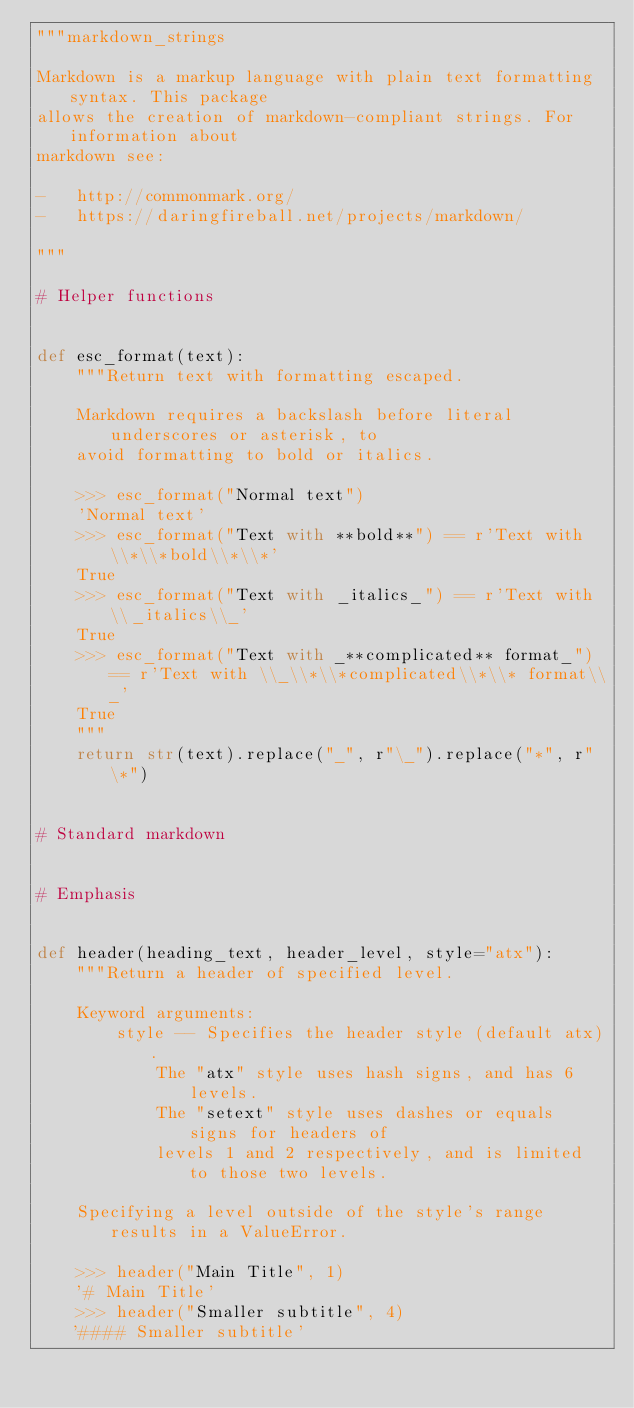Convert code to text. <code><loc_0><loc_0><loc_500><loc_500><_Python_>"""markdown_strings

Markdown is a markup language with plain text formatting syntax. This package
allows the creation of markdown-compliant strings. For information about
markdown see:

-   http://commonmark.org/
-   https://daringfireball.net/projects/markdown/

"""

# Helper functions


def esc_format(text):
    """Return text with formatting escaped.

    Markdown requires a backslash before literal underscores or asterisk, to
    avoid formatting to bold or italics.

    >>> esc_format("Normal text")
    'Normal text'
    >>> esc_format("Text with **bold**") == r'Text with \\*\\*bold\\*\\*'
    True
    >>> esc_format("Text with _italics_") == r'Text with \\_italics\\_'
    True
    >>> esc_format("Text with _**complicated** format_") == r'Text with \\_\\*\\*complicated\\*\\* format\\_'
    True
    """
    return str(text).replace("_", r"\_").replace("*", r"\*")


# Standard markdown


# Emphasis


def header(heading_text, header_level, style="atx"):
    """Return a header of specified level.

    Keyword arguments:
        style -- Specifies the header style (default atx).
            The "atx" style uses hash signs, and has 6 levels.
            The "setext" style uses dashes or equals signs for headers of
            levels 1 and 2 respectively, and is limited to those two levels.

    Specifying a level outside of the style's range results in a ValueError.

    >>> header("Main Title", 1)
    '# Main Title'
    >>> header("Smaller subtitle", 4)
    '#### Smaller subtitle'</code> 